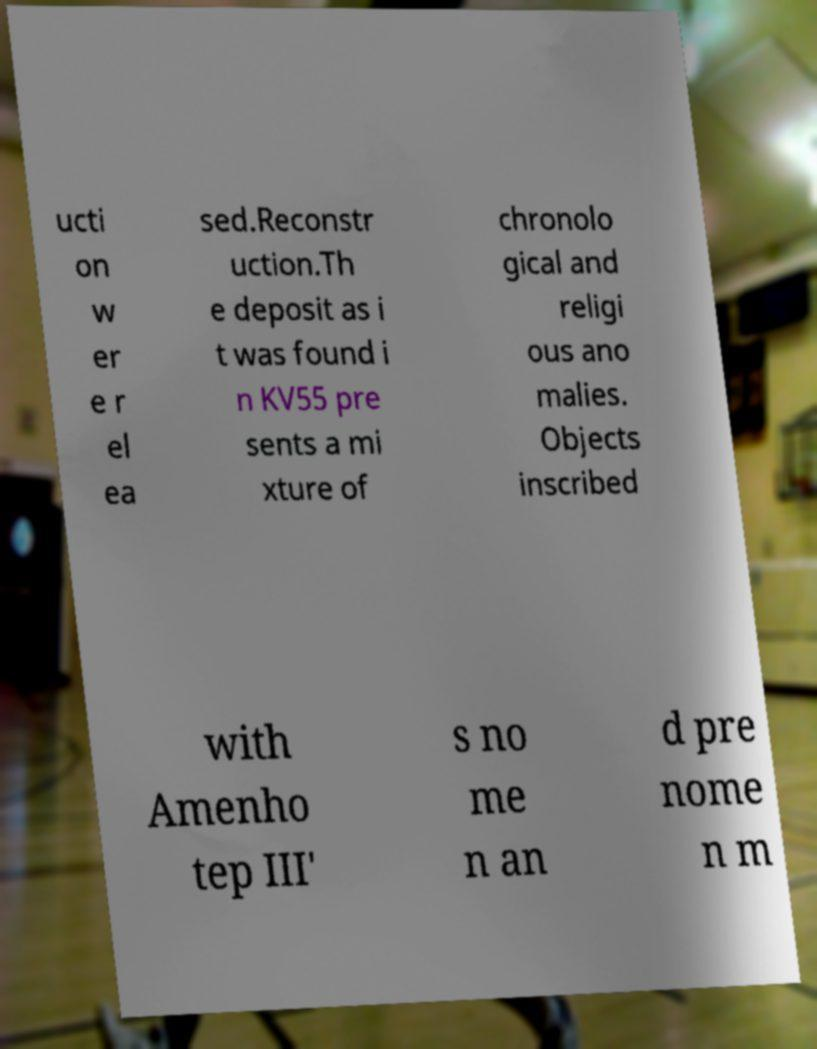Can you read and provide the text displayed in the image?This photo seems to have some interesting text. Can you extract and type it out for me? ucti on w er e r el ea sed.Reconstr uction.Th e deposit as i t was found i n KV55 pre sents a mi xture of chronolo gical and religi ous ano malies. Objects inscribed with Amenho tep III' s no me n an d pre nome n m 